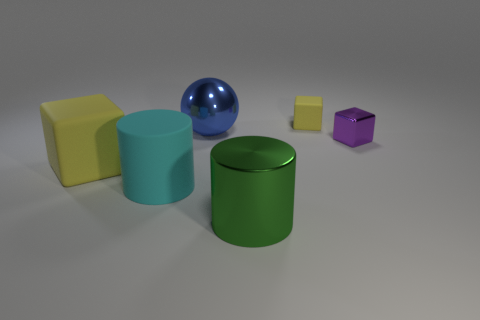There is a big cube that is the same color as the small matte cube; what is its material?
Provide a short and direct response. Rubber. What color is the thing that is right of the green thing and in front of the small yellow object?
Your response must be concise. Purple. How many big blue metallic cylinders are there?
Provide a short and direct response. 0. Does the sphere have the same size as the cyan cylinder?
Your answer should be very brief. Yes. Are there any shiny blocks of the same color as the big shiny ball?
Provide a succinct answer. No. Is the shape of the small object in front of the tiny yellow object the same as  the green object?
Keep it short and to the point. No. What number of purple balls have the same size as the blue object?
Ensure brevity in your answer.  0. There is a large object behind the small purple shiny object; what number of rubber things are to the right of it?
Give a very brief answer. 1. Are the thing that is left of the cyan matte cylinder and the big green cylinder made of the same material?
Your answer should be very brief. No. Is the yellow cube that is behind the purple metal object made of the same material as the yellow object that is in front of the small purple block?
Provide a short and direct response. Yes. 